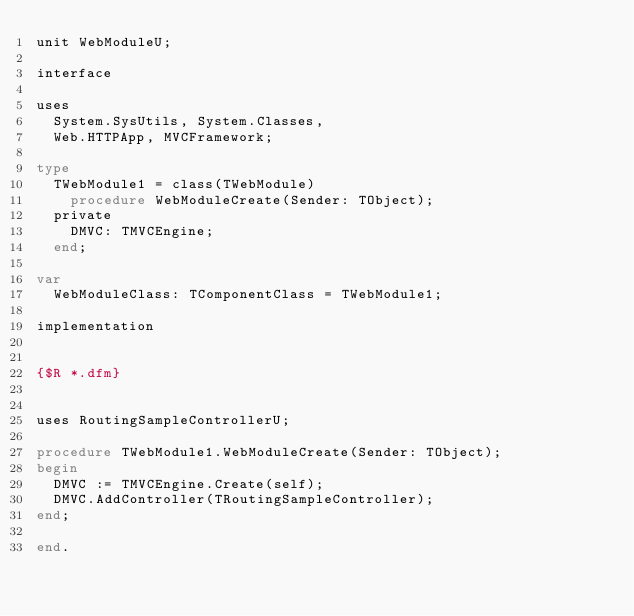<code> <loc_0><loc_0><loc_500><loc_500><_Pascal_>unit WebModuleU;

interface

uses
  System.SysUtils, System.Classes,
  Web.HTTPApp, MVCFramework;

type
  TWebModule1 = class(TWebModule)
    procedure WebModuleCreate(Sender: TObject);
  private
    DMVC: TMVCEngine;
  end;

var
  WebModuleClass: TComponentClass = TWebModule1;

implementation


{$R *.dfm}


uses RoutingSampleControllerU;

procedure TWebModule1.WebModuleCreate(Sender: TObject);
begin
  DMVC := TMVCEngine.Create(self);
  DMVC.AddController(TRoutingSampleController);
end;

end.
</code> 